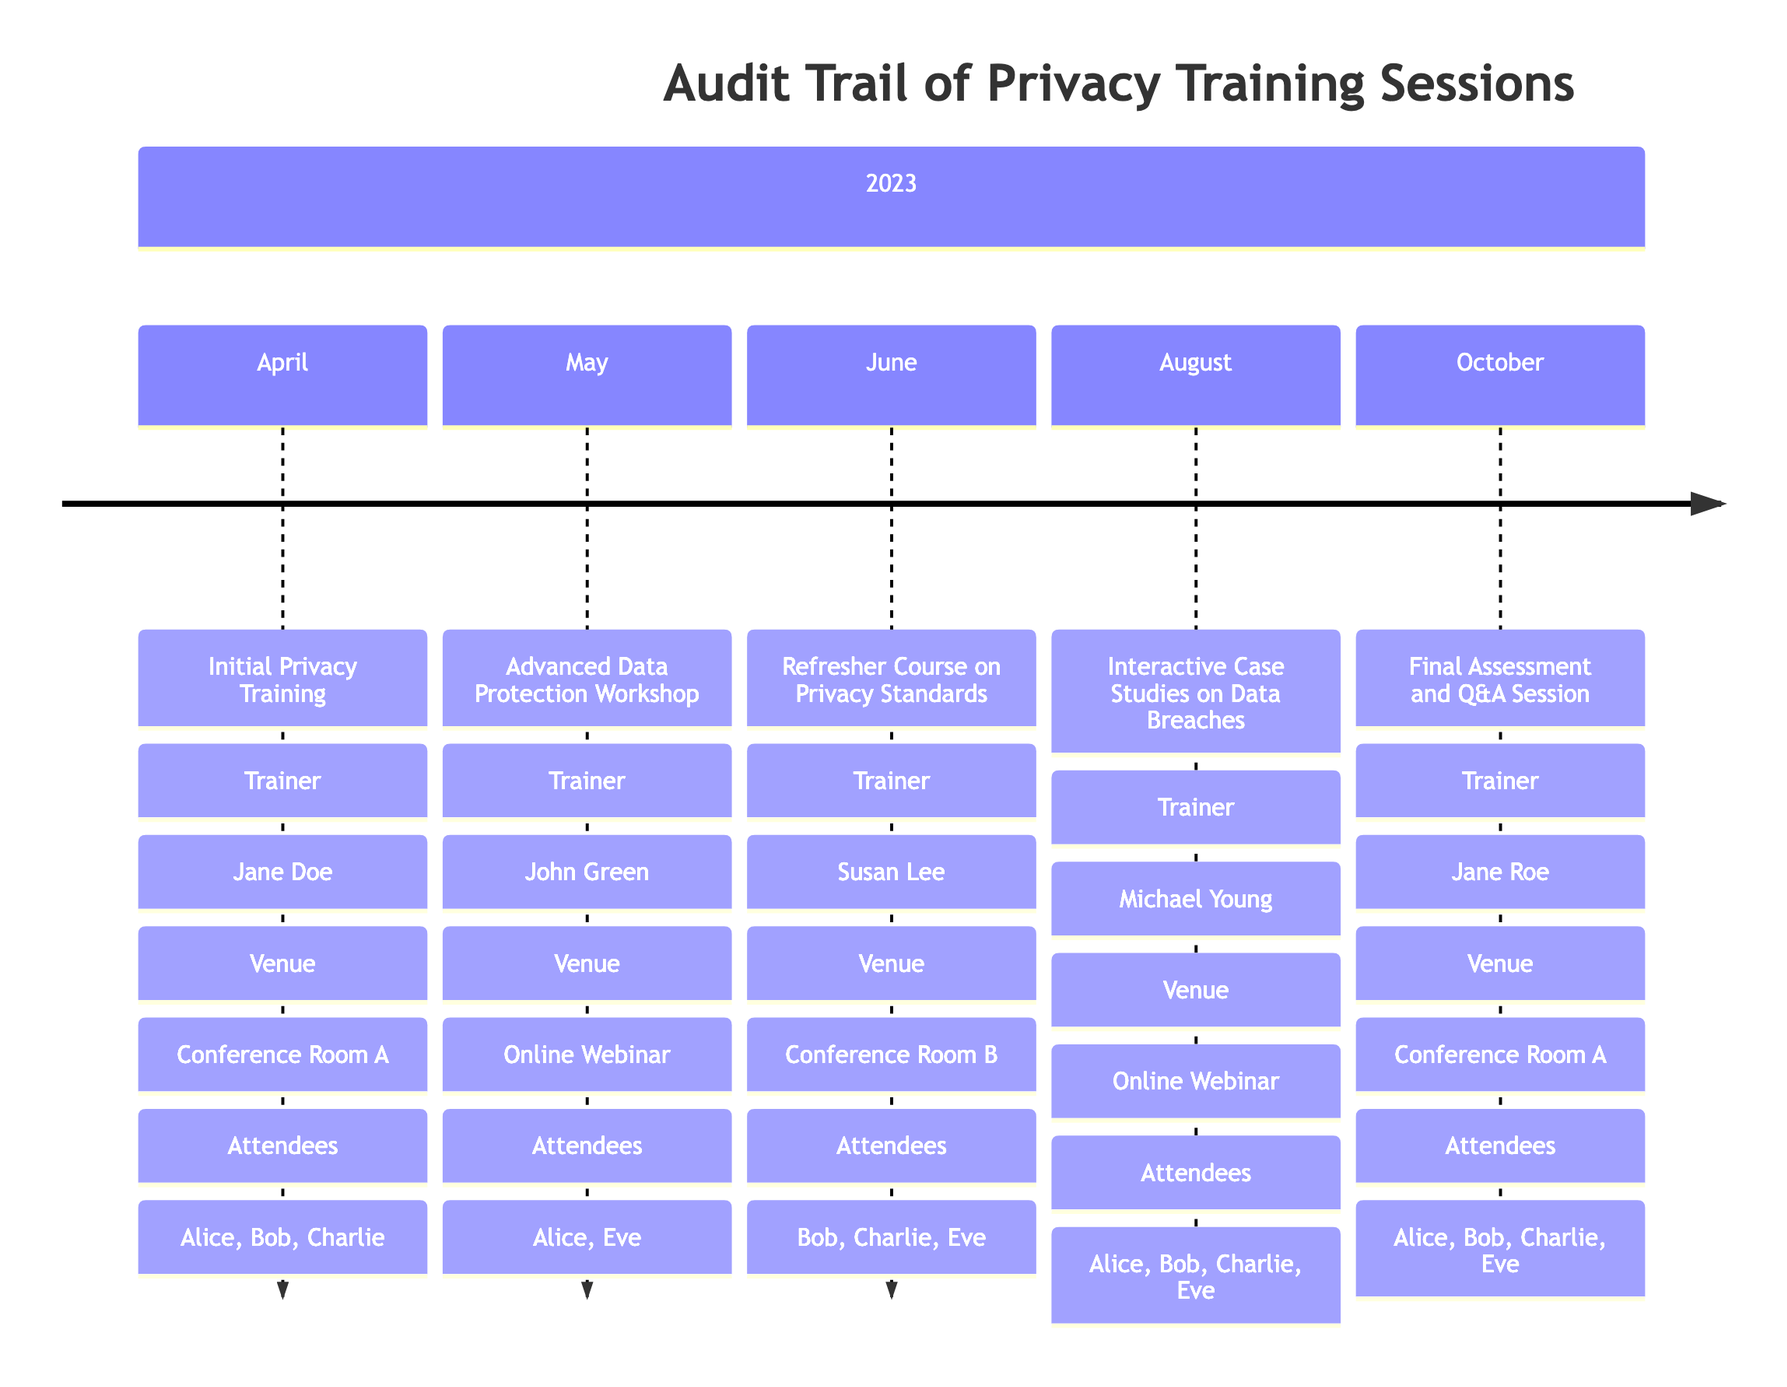What event was conducted in April 2023? The diagram shows that the event in April 2023 was the "Initial Privacy Training." I can find this information under the section labeled "April."
Answer: Initial Privacy Training Who was the trainer for the Advanced Data Protection Workshop? The workshop listed for May 2023 indicates that "John Green" was the trainer. This information is directly specified in the timeline for that month.
Answer: John Green How many attendees participated in the Interactive Case Studies on Data Breaches? For the event in August 2023, the timeline lists four attendees: Alice Smith, Bob Johnson, Charlie Brown, and Eve Wilson. I counted them based on their mention in this month's section.
Answer: 4 In which month was the Refresher Course on Privacy Standards conducted? The timeline indicates that the Refresher Course on Privacy Standards took place in June 2023. This can be confirmed by looking at the monthly breakdown.
Answer: June 2023 What materials were covered in the Final Assessment and Q&A Session? The October event's details specify that the materials covered were "Compliance Certification Test" and "Open Discussion." This is listed in the details for that event.
Answer: Compliance Certification Test, Open Discussion Which venue hosted the Interactive Case Studies on Data Breaches? According to the timeline, the venue for the August event was an "Online Webinar." This is indicated specifically next to the details of that event.
Answer: Online Webinar How many total training sessions were conducted over the six months? Counting the events listed in the timeline from April to October, there are a total of five distinct training sessions. Thus, I counted each event provided in the timeline.
Answer: 5 Which team member attended the most sessions? By analyzing the attendees for each session, I can see that "Alice Smith" attended all five training events, which makes her the most frequent attendee. I compared the attendee lists across all months to determine this.
Answer: Alice Smith What was the main focus of the training in May 2023? The event in May 2023, which was the Advanced Data Protection Workshop, focused on "Data Encryption" and "Anonymization Techniques" as materials covered. I looked for the details specified under that month.
Answer: Data Encryption, Anonymization Techniques 